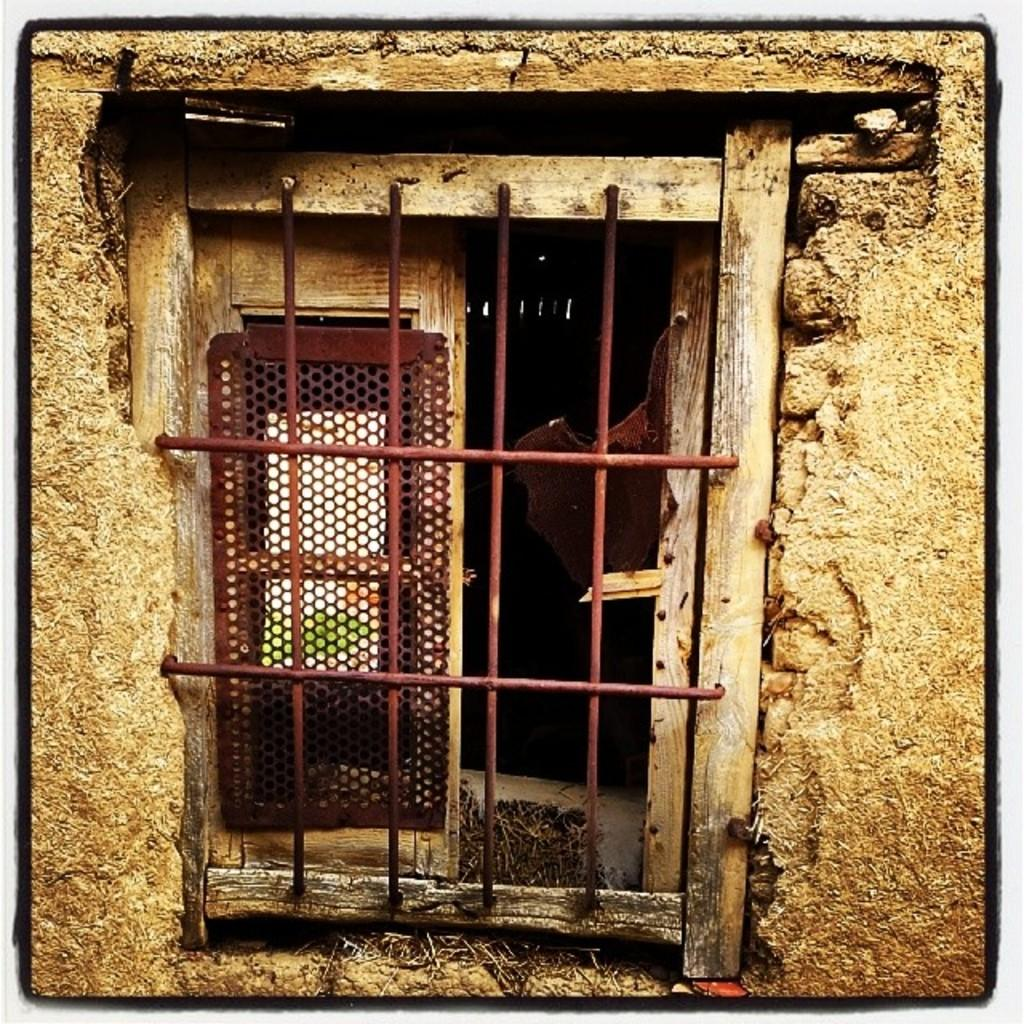What type of structure can be seen in the image? There is a wall in the image. What architectural feature is present in the wall? There is a window in the image. What type of material is used for the window feature? There is an iron grill in the image, which suggests that the window may have an iron grill. What type of curve can be seen in the image? There is no curve present in the image; it features a wall, a window, and an iron grill. What type of cord is visible in the image? There is no cord present in the image. 